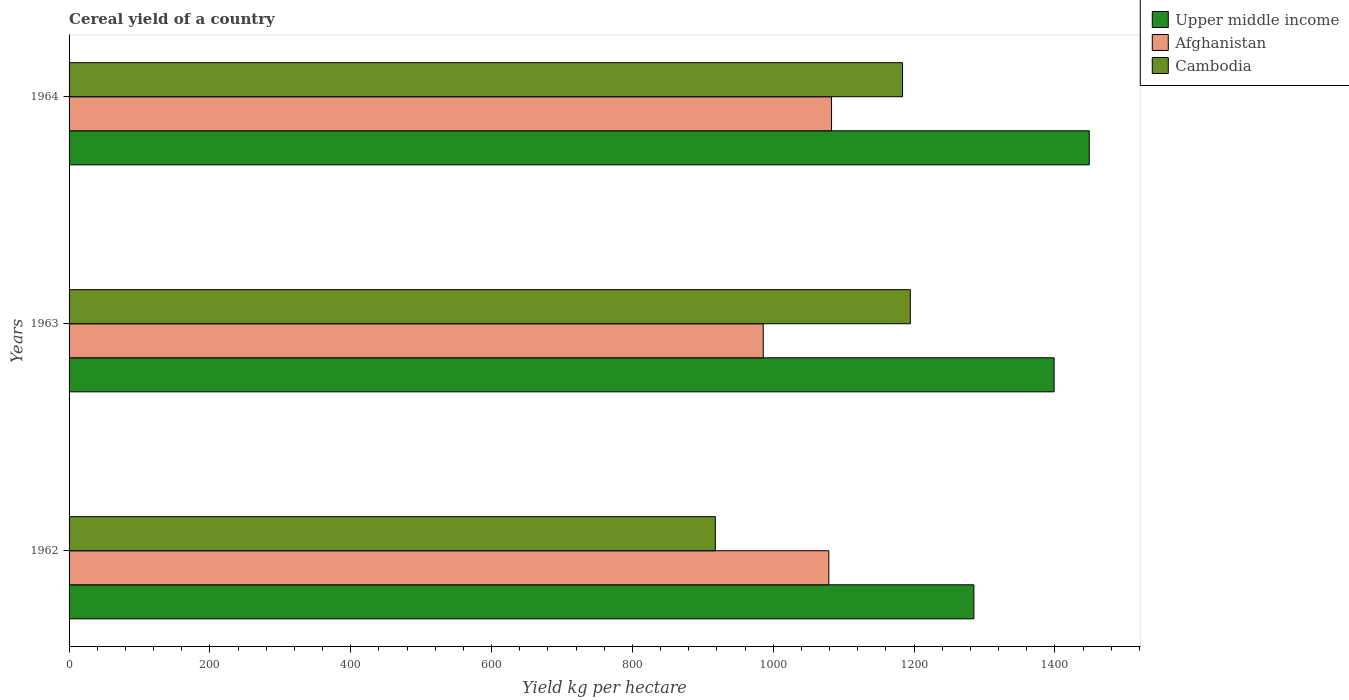Are the number of bars per tick equal to the number of legend labels?
Provide a short and direct response. Yes. Are the number of bars on each tick of the Y-axis equal?
Your answer should be very brief. Yes. How many bars are there on the 2nd tick from the top?
Offer a terse response. 3. How many bars are there on the 2nd tick from the bottom?
Make the answer very short. 3. In how many cases, is the number of bars for a given year not equal to the number of legend labels?
Offer a terse response. 0. What is the total cereal yield in Cambodia in 1964?
Your response must be concise. 1183.67. Across all years, what is the maximum total cereal yield in Cambodia?
Your answer should be compact. 1194.72. Across all years, what is the minimum total cereal yield in Upper middle income?
Give a very brief answer. 1284.98. In which year was the total cereal yield in Upper middle income maximum?
Your answer should be compact. 1964. What is the total total cereal yield in Cambodia in the graph?
Offer a very short reply. 3296.16. What is the difference between the total cereal yield in Upper middle income in 1962 and that in 1963?
Offer a very short reply. -113.93. What is the difference between the total cereal yield in Upper middle income in 1964 and the total cereal yield in Cambodia in 1963?
Keep it short and to the point. 254.11. What is the average total cereal yield in Afghanistan per year?
Give a very brief answer. 1049.22. In the year 1962, what is the difference between the total cereal yield in Upper middle income and total cereal yield in Afghanistan?
Keep it short and to the point. 206.01. What is the ratio of the total cereal yield in Upper middle income in 1962 to that in 1964?
Make the answer very short. 0.89. What is the difference between the highest and the second highest total cereal yield in Afghanistan?
Provide a succinct answer. 3.87. What is the difference between the highest and the lowest total cereal yield in Cambodia?
Make the answer very short. 276.94. What does the 3rd bar from the top in 1964 represents?
Make the answer very short. Upper middle income. What does the 3rd bar from the bottom in 1964 represents?
Give a very brief answer. Cambodia. Is it the case that in every year, the sum of the total cereal yield in Cambodia and total cereal yield in Afghanistan is greater than the total cereal yield in Upper middle income?
Offer a very short reply. Yes. How many years are there in the graph?
Provide a short and direct response. 3. What is the difference between two consecutive major ticks on the X-axis?
Give a very brief answer. 200. Does the graph contain any zero values?
Provide a succinct answer. No. Where does the legend appear in the graph?
Your answer should be very brief. Top right. How are the legend labels stacked?
Give a very brief answer. Vertical. What is the title of the graph?
Offer a terse response. Cereal yield of a country. Does "Togo" appear as one of the legend labels in the graph?
Your answer should be compact. No. What is the label or title of the X-axis?
Keep it short and to the point. Yield kg per hectare. What is the Yield kg per hectare of Upper middle income in 1962?
Provide a short and direct response. 1284.98. What is the Yield kg per hectare in Afghanistan in 1962?
Your response must be concise. 1078.97. What is the Yield kg per hectare in Cambodia in 1962?
Offer a terse response. 917.78. What is the Yield kg per hectare in Upper middle income in 1963?
Provide a succinct answer. 1398.9. What is the Yield kg per hectare in Afghanistan in 1963?
Offer a very short reply. 985.85. What is the Yield kg per hectare of Cambodia in 1963?
Offer a very short reply. 1194.72. What is the Yield kg per hectare of Upper middle income in 1964?
Make the answer very short. 1448.83. What is the Yield kg per hectare of Afghanistan in 1964?
Make the answer very short. 1082.84. What is the Yield kg per hectare of Cambodia in 1964?
Offer a very short reply. 1183.67. Across all years, what is the maximum Yield kg per hectare of Upper middle income?
Your answer should be very brief. 1448.83. Across all years, what is the maximum Yield kg per hectare in Afghanistan?
Give a very brief answer. 1082.84. Across all years, what is the maximum Yield kg per hectare of Cambodia?
Make the answer very short. 1194.72. Across all years, what is the minimum Yield kg per hectare in Upper middle income?
Your response must be concise. 1284.98. Across all years, what is the minimum Yield kg per hectare of Afghanistan?
Keep it short and to the point. 985.85. Across all years, what is the minimum Yield kg per hectare in Cambodia?
Provide a succinct answer. 917.78. What is the total Yield kg per hectare of Upper middle income in the graph?
Ensure brevity in your answer.  4132.7. What is the total Yield kg per hectare of Afghanistan in the graph?
Your answer should be very brief. 3147.65. What is the total Yield kg per hectare in Cambodia in the graph?
Your answer should be compact. 3296.16. What is the difference between the Yield kg per hectare of Upper middle income in 1962 and that in 1963?
Keep it short and to the point. -113.93. What is the difference between the Yield kg per hectare in Afghanistan in 1962 and that in 1963?
Your answer should be very brief. 93.12. What is the difference between the Yield kg per hectare of Cambodia in 1962 and that in 1963?
Ensure brevity in your answer.  -276.94. What is the difference between the Yield kg per hectare of Upper middle income in 1962 and that in 1964?
Provide a short and direct response. -163.85. What is the difference between the Yield kg per hectare in Afghanistan in 1962 and that in 1964?
Give a very brief answer. -3.87. What is the difference between the Yield kg per hectare of Cambodia in 1962 and that in 1964?
Provide a succinct answer. -265.89. What is the difference between the Yield kg per hectare in Upper middle income in 1963 and that in 1964?
Give a very brief answer. -49.93. What is the difference between the Yield kg per hectare of Afghanistan in 1963 and that in 1964?
Keep it short and to the point. -96.99. What is the difference between the Yield kg per hectare of Cambodia in 1963 and that in 1964?
Your response must be concise. 11.05. What is the difference between the Yield kg per hectare of Upper middle income in 1962 and the Yield kg per hectare of Afghanistan in 1963?
Provide a short and direct response. 299.13. What is the difference between the Yield kg per hectare in Upper middle income in 1962 and the Yield kg per hectare in Cambodia in 1963?
Offer a very short reply. 90.26. What is the difference between the Yield kg per hectare of Afghanistan in 1962 and the Yield kg per hectare of Cambodia in 1963?
Provide a succinct answer. -115.75. What is the difference between the Yield kg per hectare in Upper middle income in 1962 and the Yield kg per hectare in Afghanistan in 1964?
Offer a very short reply. 202.14. What is the difference between the Yield kg per hectare of Upper middle income in 1962 and the Yield kg per hectare of Cambodia in 1964?
Your answer should be very brief. 101.31. What is the difference between the Yield kg per hectare of Afghanistan in 1962 and the Yield kg per hectare of Cambodia in 1964?
Offer a very short reply. -104.7. What is the difference between the Yield kg per hectare of Upper middle income in 1963 and the Yield kg per hectare of Afghanistan in 1964?
Provide a short and direct response. 316.06. What is the difference between the Yield kg per hectare of Upper middle income in 1963 and the Yield kg per hectare of Cambodia in 1964?
Your answer should be compact. 215.24. What is the difference between the Yield kg per hectare of Afghanistan in 1963 and the Yield kg per hectare of Cambodia in 1964?
Provide a short and direct response. -197.82. What is the average Yield kg per hectare in Upper middle income per year?
Provide a succinct answer. 1377.57. What is the average Yield kg per hectare of Afghanistan per year?
Give a very brief answer. 1049.22. What is the average Yield kg per hectare in Cambodia per year?
Provide a short and direct response. 1098.72. In the year 1962, what is the difference between the Yield kg per hectare of Upper middle income and Yield kg per hectare of Afghanistan?
Your answer should be compact. 206.01. In the year 1962, what is the difference between the Yield kg per hectare in Upper middle income and Yield kg per hectare in Cambodia?
Your answer should be compact. 367.2. In the year 1962, what is the difference between the Yield kg per hectare in Afghanistan and Yield kg per hectare in Cambodia?
Keep it short and to the point. 161.19. In the year 1963, what is the difference between the Yield kg per hectare in Upper middle income and Yield kg per hectare in Afghanistan?
Make the answer very short. 413.06. In the year 1963, what is the difference between the Yield kg per hectare of Upper middle income and Yield kg per hectare of Cambodia?
Your response must be concise. 204.18. In the year 1963, what is the difference between the Yield kg per hectare in Afghanistan and Yield kg per hectare in Cambodia?
Your answer should be very brief. -208.87. In the year 1964, what is the difference between the Yield kg per hectare in Upper middle income and Yield kg per hectare in Afghanistan?
Make the answer very short. 365.99. In the year 1964, what is the difference between the Yield kg per hectare in Upper middle income and Yield kg per hectare in Cambodia?
Offer a terse response. 265.16. In the year 1964, what is the difference between the Yield kg per hectare of Afghanistan and Yield kg per hectare of Cambodia?
Offer a very short reply. -100.83. What is the ratio of the Yield kg per hectare of Upper middle income in 1962 to that in 1963?
Your answer should be very brief. 0.92. What is the ratio of the Yield kg per hectare in Afghanistan in 1962 to that in 1963?
Keep it short and to the point. 1.09. What is the ratio of the Yield kg per hectare in Cambodia in 1962 to that in 1963?
Your answer should be compact. 0.77. What is the ratio of the Yield kg per hectare in Upper middle income in 1962 to that in 1964?
Your answer should be very brief. 0.89. What is the ratio of the Yield kg per hectare of Afghanistan in 1962 to that in 1964?
Your answer should be compact. 1. What is the ratio of the Yield kg per hectare of Cambodia in 1962 to that in 1964?
Ensure brevity in your answer.  0.78. What is the ratio of the Yield kg per hectare in Upper middle income in 1963 to that in 1964?
Ensure brevity in your answer.  0.97. What is the ratio of the Yield kg per hectare in Afghanistan in 1963 to that in 1964?
Keep it short and to the point. 0.91. What is the ratio of the Yield kg per hectare of Cambodia in 1963 to that in 1964?
Provide a short and direct response. 1.01. What is the difference between the highest and the second highest Yield kg per hectare in Upper middle income?
Provide a succinct answer. 49.93. What is the difference between the highest and the second highest Yield kg per hectare in Afghanistan?
Your answer should be compact. 3.87. What is the difference between the highest and the second highest Yield kg per hectare of Cambodia?
Keep it short and to the point. 11.05. What is the difference between the highest and the lowest Yield kg per hectare in Upper middle income?
Make the answer very short. 163.85. What is the difference between the highest and the lowest Yield kg per hectare in Afghanistan?
Offer a terse response. 96.99. What is the difference between the highest and the lowest Yield kg per hectare in Cambodia?
Provide a short and direct response. 276.94. 